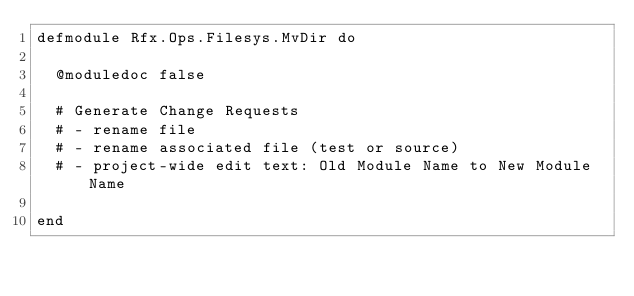Convert code to text. <code><loc_0><loc_0><loc_500><loc_500><_Elixir_>defmodule Rfx.Ops.Filesys.MvDir do

  @moduledoc false

  # Generate Change Requests
  # - rename file
  # - rename associated file (test or source)
  # - project-wide edit text: Old Module Name to New Module Name
  
end
</code> 